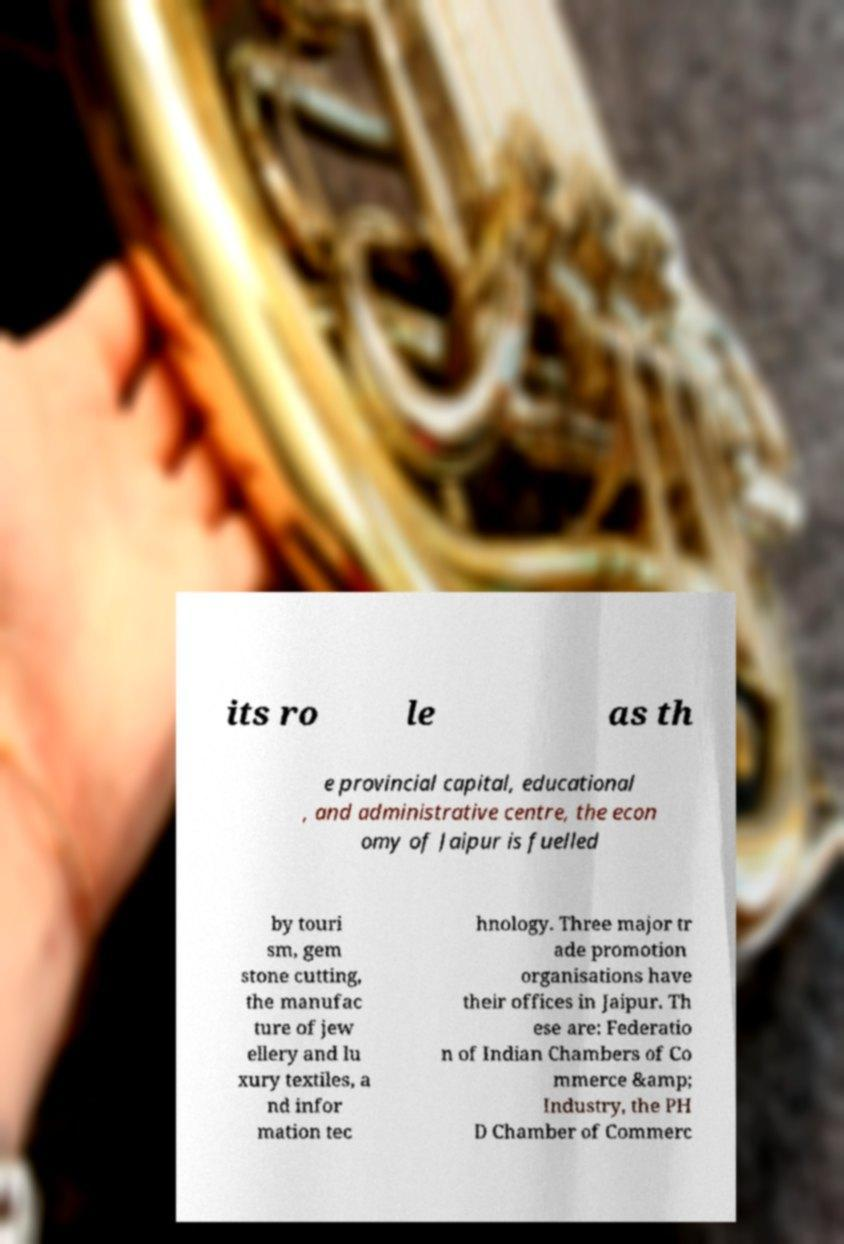There's text embedded in this image that I need extracted. Can you transcribe it verbatim? its ro le as th e provincial capital, educational , and administrative centre, the econ omy of Jaipur is fuelled by touri sm, gem stone cutting, the manufac ture of jew ellery and lu xury textiles, a nd infor mation tec hnology. Three major tr ade promotion organisations have their offices in Jaipur. Th ese are: Federatio n of Indian Chambers of Co mmerce &amp; Industry, the PH D Chamber of Commerc 